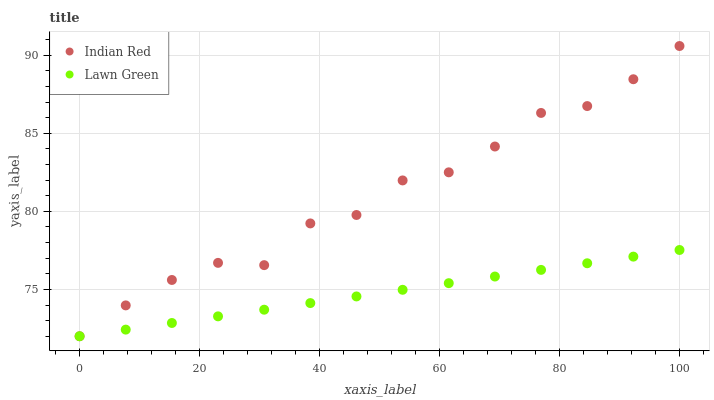Does Lawn Green have the minimum area under the curve?
Answer yes or no. Yes. Does Indian Red have the maximum area under the curve?
Answer yes or no. Yes. Does Indian Red have the minimum area under the curve?
Answer yes or no. No. Is Lawn Green the smoothest?
Answer yes or no. Yes. Is Indian Red the roughest?
Answer yes or no. Yes. Is Indian Red the smoothest?
Answer yes or no. No. Does Lawn Green have the lowest value?
Answer yes or no. Yes. Does Indian Red have the highest value?
Answer yes or no. Yes. Does Indian Red intersect Lawn Green?
Answer yes or no. Yes. Is Indian Red less than Lawn Green?
Answer yes or no. No. Is Indian Red greater than Lawn Green?
Answer yes or no. No. 